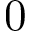<formula> <loc_0><loc_0><loc_500><loc_500>0</formula> 